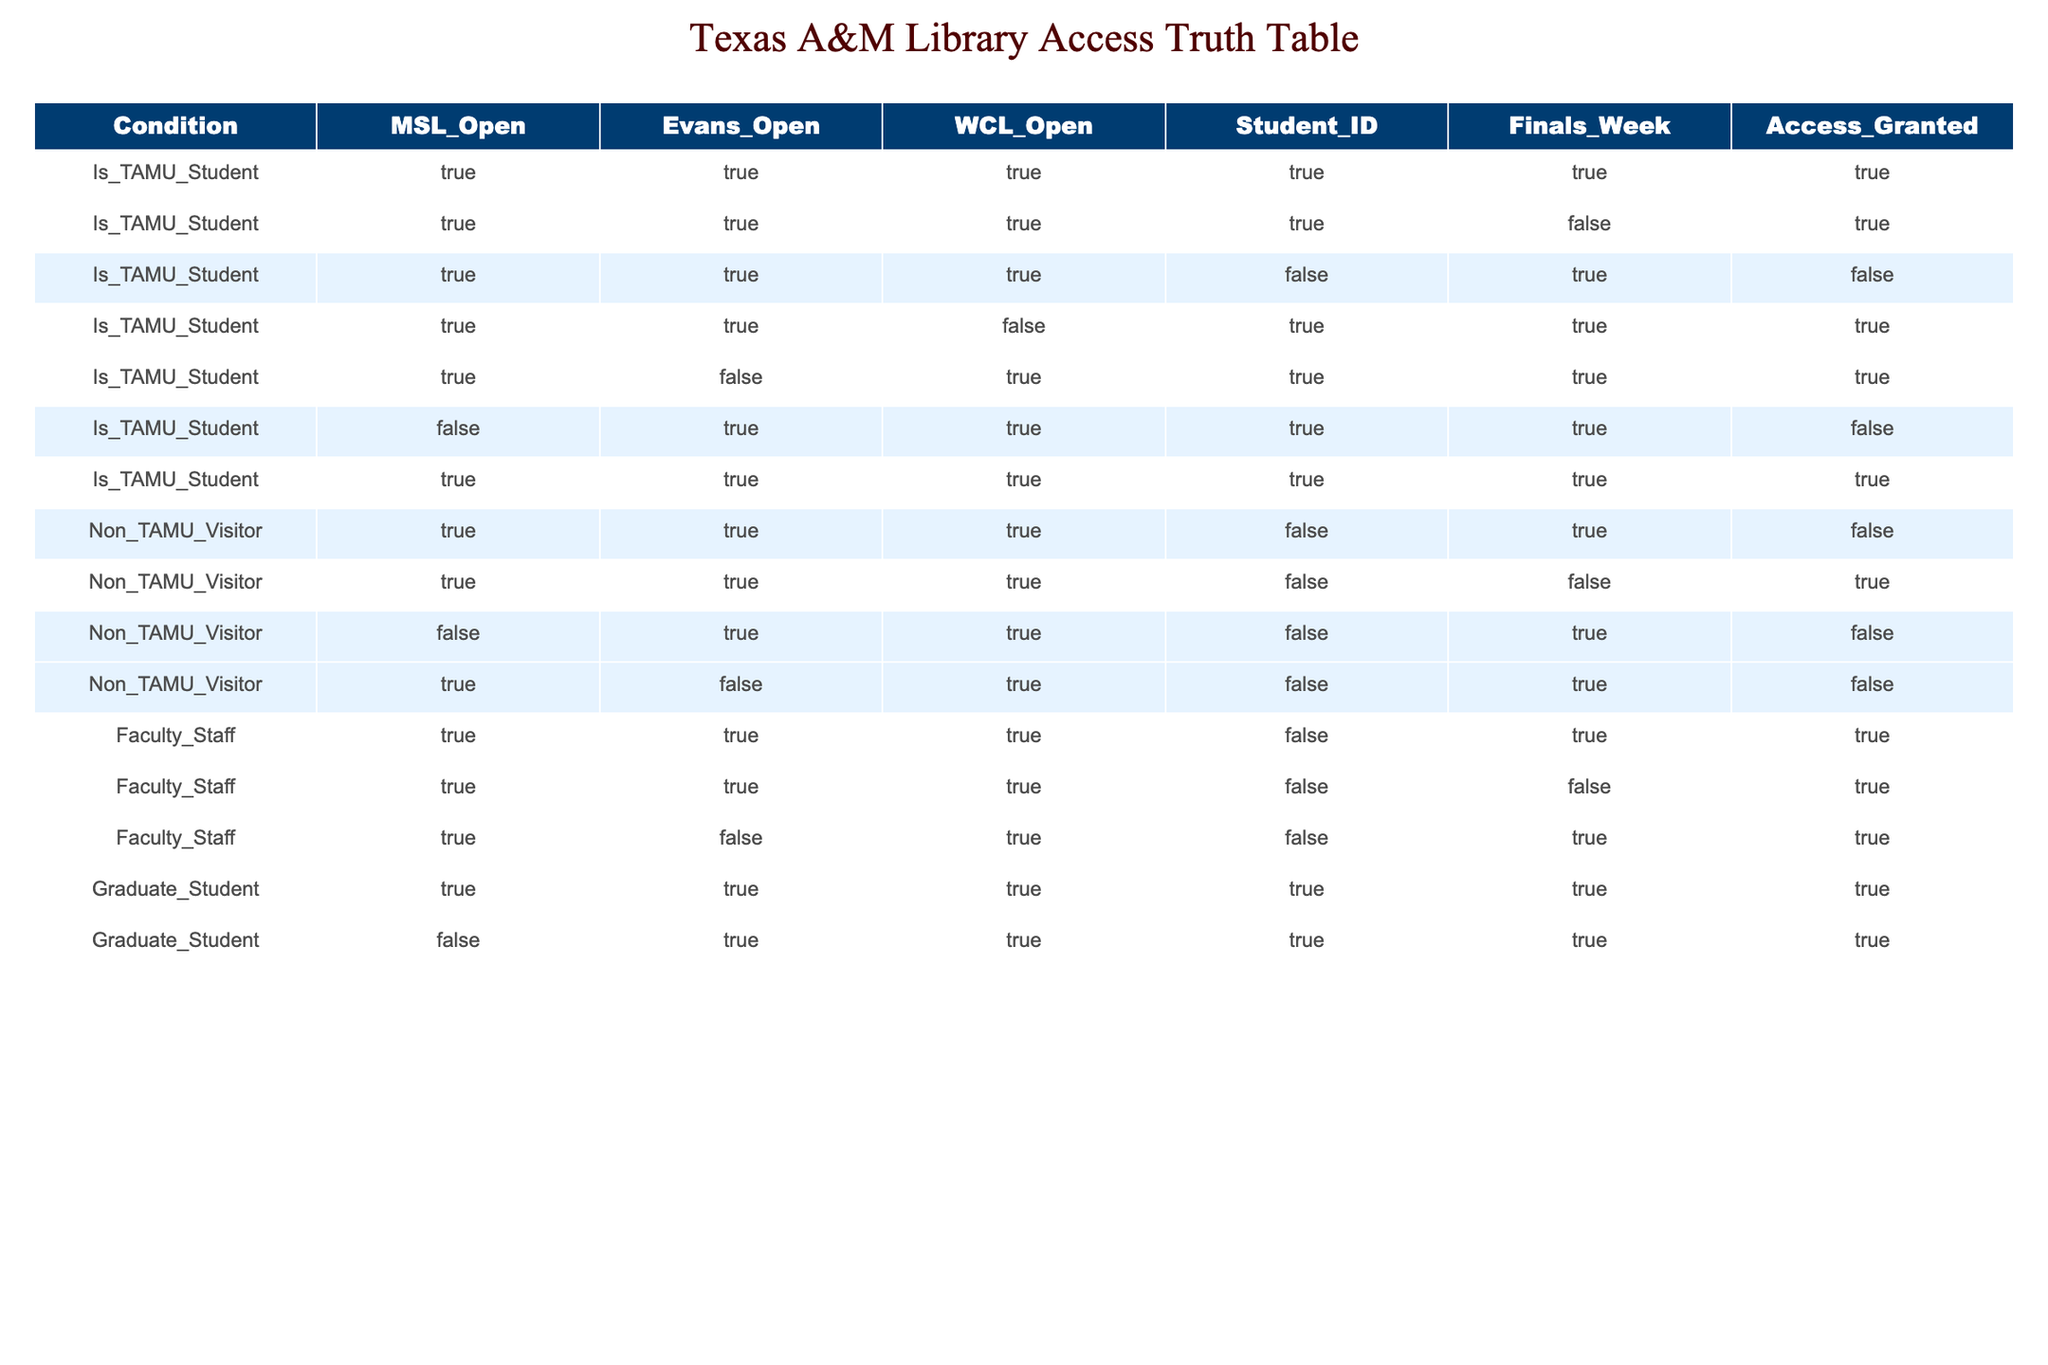Is MSL open to a TAMU student during finals week? For a TAMU student during finals week, the row shows that MSL is open for access as indicated in the rows with "Is_TAMU_Student" and "Finals_Week" as TRUE. Thus, MSL is open.
Answer: YES Can a non-TAMU visitor access the WCL during finals week? For a non-TAMU visitor, the rows indicate that WCL access is denied during finals week since the "Access_Granted" value is FALSE in all instances where "Is_TAMU_Student" is FALSE and "Finals_Week" is TRUE.
Answer: NO How many groups have full access to all three libraries during finals week? The rows show combinations of access. Counting the rows, TAMU students and faculty/staff all have full access during finals week (total of 4 distinct rows), totaling 6 groups that can access all libraries.
Answer: 6 Is access to Evans Library granted for graduate students during non-finals week? Review the two rows for "Graduate_Student" where "Finals_Week" is FALSE. They show both cases grant open access status, indicating graduate students have access to Evans Library outside of finals week.
Answer: YES If someone is faculty staff but not a TAMU student, can they access MSL during finals week? Reviewing the table, all instances of faculty staff show that they are granted access, irrespective of being TAMU students or not. Therefore, they have access to MSL regardless of student status during finals week.
Answer: YES Are there any cases where a non-TAMU visitor can access WCL during finals week? Upon checking, there are no rows where "Non_TAMU_Visitor" has "Access_Granted" as TRUE while the "Finals_Week" is TRUE for WCL. Thus, access is denied for all cases.
Answer: NO What percentage of TAMU students have access to Evans Library during finals week? Counting the instances where "Is_TAMU_Student" is TRUE, all 5 rows with that condition grant access. Thus, 100% of TAMU students have access to Evans Library during finals week.
Answer: 100% Does any group have restricted access to MSL during finals week while being affiliated with the university? Analyzing the table, the rows indicate that for both faculty/staff and graduate students (affiliated groups), there is no restricted access to MSL during finals week. Thus, none in this category are restricted.
Answer: NO 